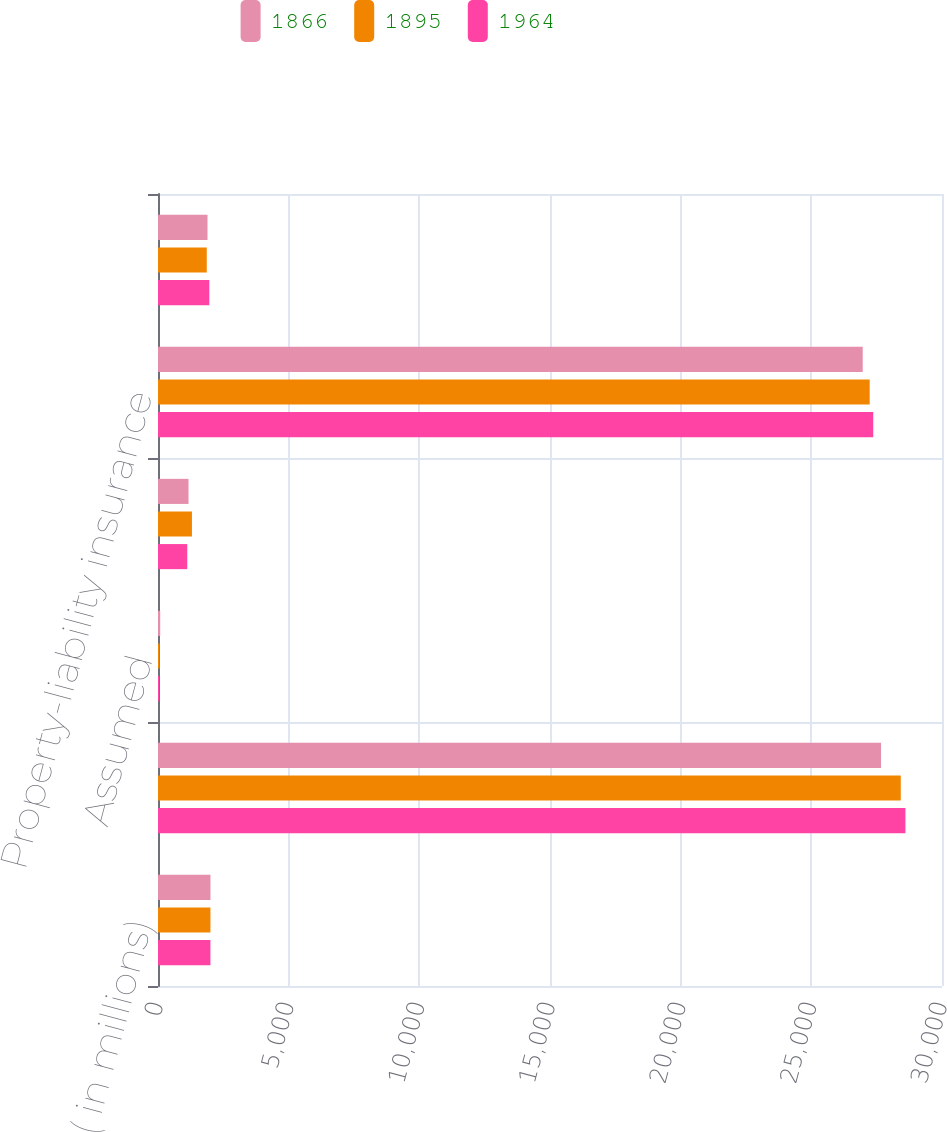<chart> <loc_0><loc_0><loc_500><loc_500><stacked_bar_chart><ecel><fcel>( in millions)<fcel>Direct<fcel>Assumed<fcel>Ceded<fcel>Property-liability insurance<fcel>Life and annuity premiums and<nl><fcel>1866<fcel>2008<fcel>27667<fcel>85<fcel>1168<fcel>26967<fcel>1895<nl><fcel>1895<fcel>2007<fcel>28423<fcel>59<fcel>1299<fcel>27233<fcel>1866<nl><fcel>1964<fcel>2006<fcel>28601<fcel>44<fcel>1119<fcel>27369<fcel>1964<nl></chart> 